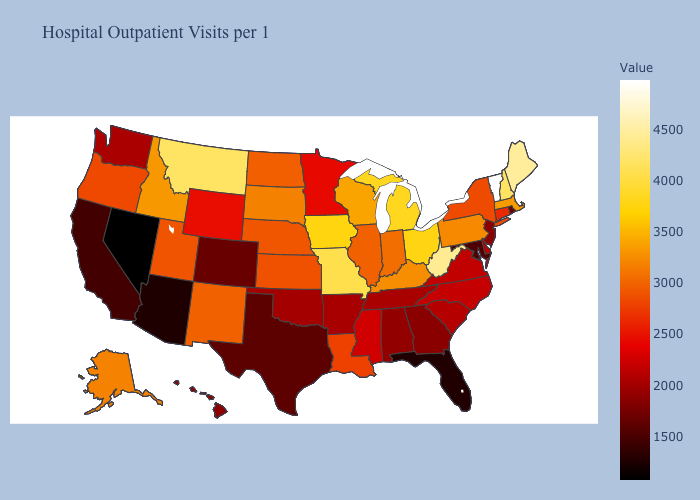Which states have the lowest value in the MidWest?
Be succinct. Minnesota. Does Delaware have the lowest value in the USA?
Concise answer only. No. Does Utah have a lower value than Delaware?
Keep it brief. No. Which states have the lowest value in the USA?
Concise answer only. Nevada. Does Indiana have a higher value than Missouri?
Write a very short answer. No. 